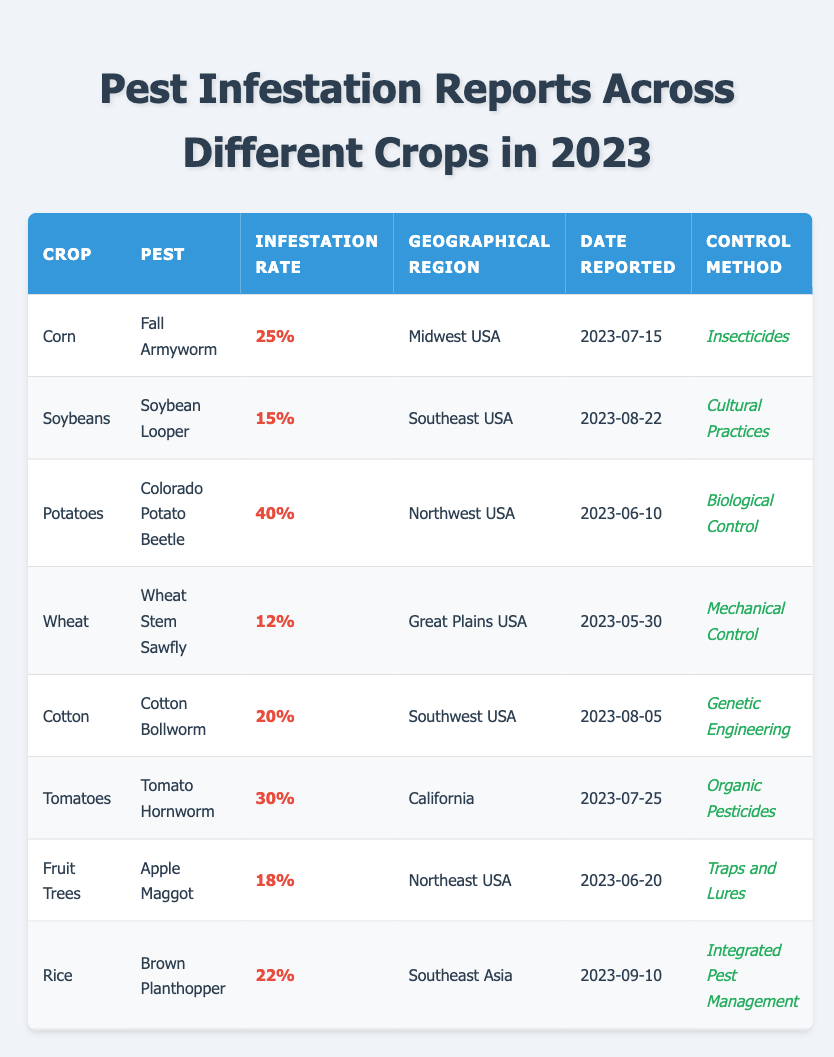What pest affected potatoes? The table shows that the crop "Potatoes" was affected by the "Colorado Potato Beetle."
Answer: Colorado Potato Beetle What is the infestation rate for corn? According to the table, the infestation rate for the crop "Corn" is listed as 25%.
Answer: 25% Which crop experienced the highest infestation rate? By comparing the values in the "Infestation Rate" column, "Potatoes" has the highest infestation rate at 40%.
Answer: Potatoes How many crops have an infestation rate of over 20%? By analyzing the table, the crops with infestation rates over 20% are "Potatoes" (40%), "Tomatoes" (30%), and "Corn" (25%). This totals three crops.
Answer: 3 What control method was used for cotton? The table indicates that the control method for the crop "Cotton" is "Genetic Engineering."
Answer: Genetic Engineering Is the infestation rate for wheat lower than that for soybeans? The infestation rate for "Wheat" is 12% and for "Soybeans" is 15%, meaning that yes, wheat's infestation rate is lower than soybeans'.
Answer: Yes What is the geographical region for the tomato pest? The table specifies that the geographical region for the crop "Tomatoes" is "California."
Answer: California Which pest was reported in the Northeast USA? The table indicates that "Apple Maggot" is the pest reported for the crop "Fruit Trees" in the "Northeast USA."
Answer: Apple Maggot What is the average infestation rate of all crops listed? The infestation rates are 25%, 15%, 40%, 12%, 20%, 30%, 18%, and 22%. Adding these yields a total of 172%. Dividing by 8 (the number of crops) gives an average of 21.5%.
Answer: 21.5% Which crop was reported last and what was its infestation rate? The last report was for "Rice" on 2023-09-10, with an infestation rate of 22%.
Answer: Rice, 22% 